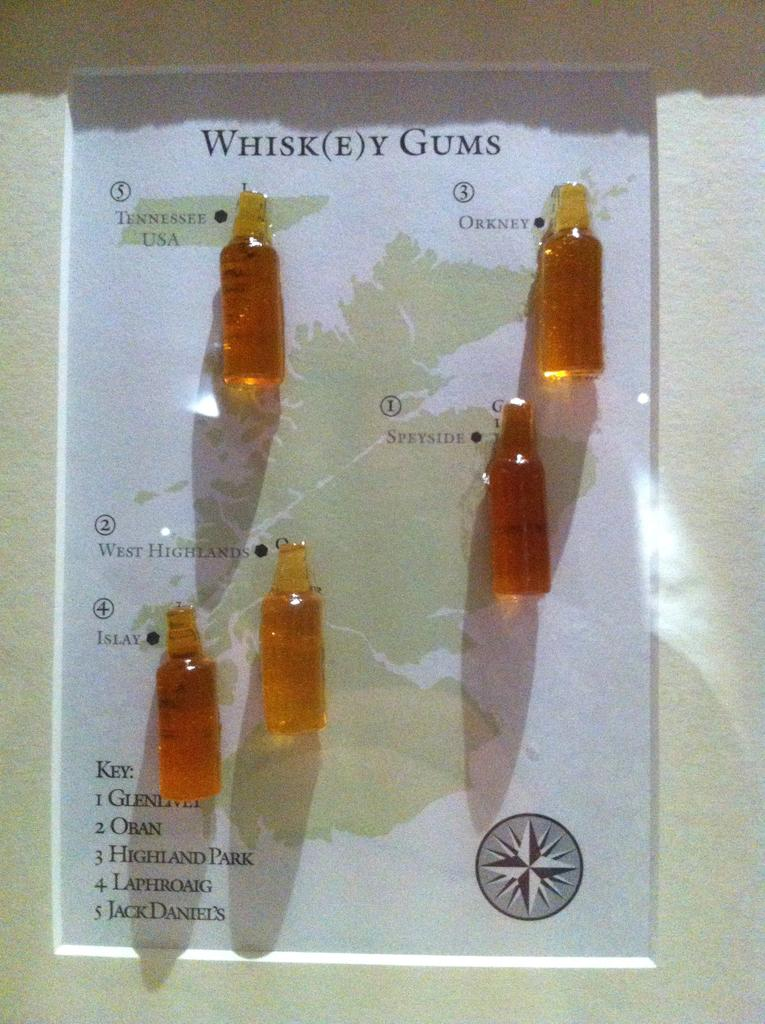<image>
Render a clear and concise summary of the photo. Mini bottles of whiskey gums are on display. 